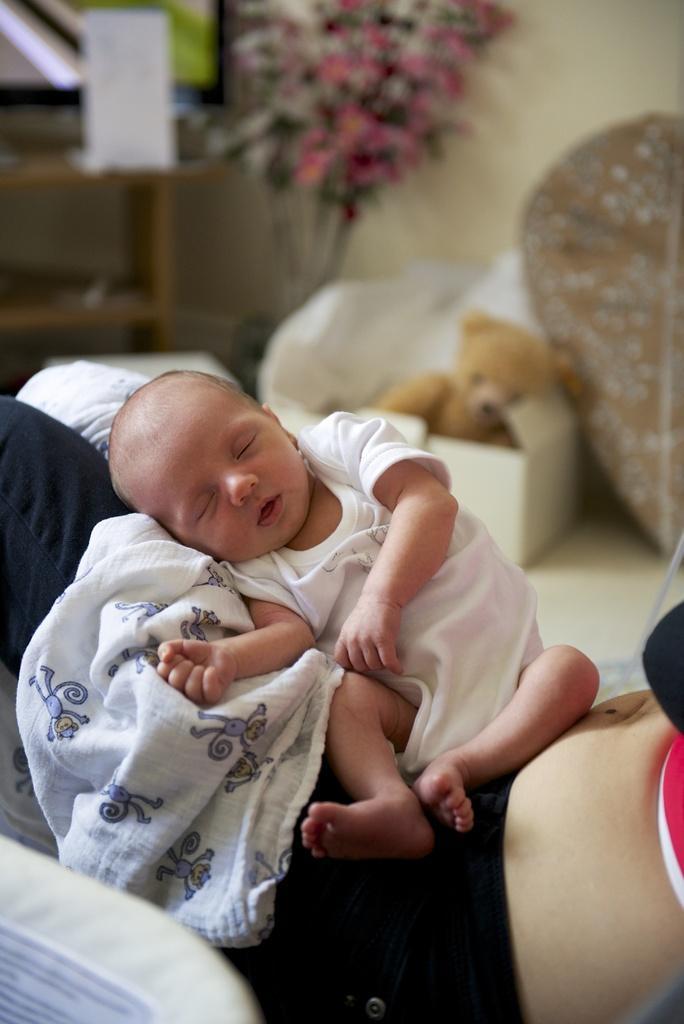Can you describe this image briefly? In this picture there is a small baby sleeping on the mother laps wearing black color track. Behind we can see the box with brown color teddy bear and some flower pot. 